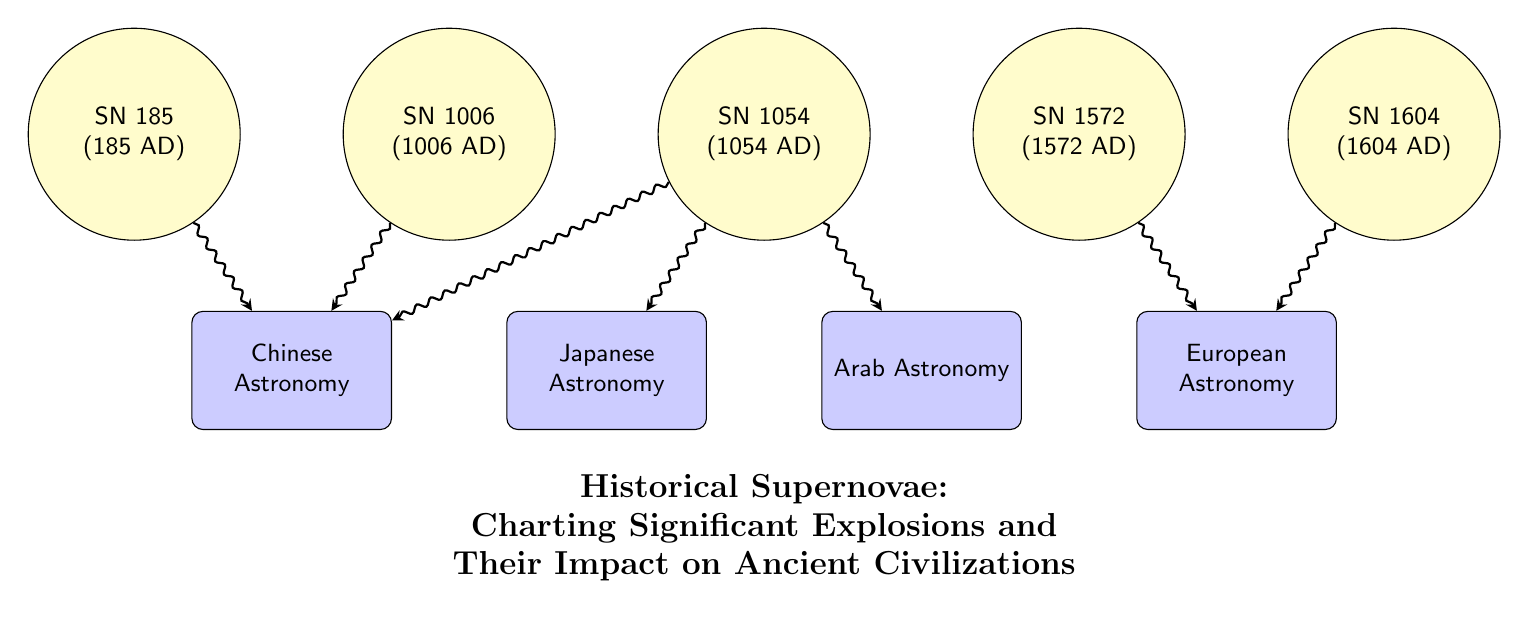What is the earliest supernova listed in the diagram? The diagram identifies five historical supernova events, the earliest being SN 185, which occurred in 185 AD.
Answer: SN 185 How many supernovae are connected to Chinese Astronomy? The diagram shows connections from three supernovae events (SN 185, SN 1006, and SN 1054) to Chinese Astronomy.
Answer: 3 Which civilization is linked to SN 1054? The diagram connects SN 1054 to three civilizations: Chinese Astronomy, Japanese Astronomy, and Arab Astronomy. Therefore, any of these could be an answer, but since the question asks for any specific civilization, we can refer to the first in the order listed.
Answer: Chinese Astronomy What event corresponds to the year 1604? From the diagram, the event labeled SN 1604 corresponds to the year 1604.
Answer: SN 1604 Which two historical supernovae are connected to European Astronomy? The connections indicate that SN 1572 and SN 1604 are linked with European Astronomy in the diagram.
Answer: SN 1572 and SN 1604 How many civilizations are depicted in the diagram? The diagram presents four civilizations: Chinese Astronomy, Japanese Astronomy, Arab Astronomy, and European Astronomy.
Answer: 4 What is the relationship between SN 1054 and Japanese Astronomy? The diagram shows a direct connection from SN 1054 to Japanese Astronomy, indicating a relationship where this supernova is significant to the Japanese astronomical community.
Answer: Connection Which supernova event is associated with Arab Astronomy? According to the diagram, SN 1054 is indicated as the supernova event associated with Arab Astronomy.
Answer: SN 1054 